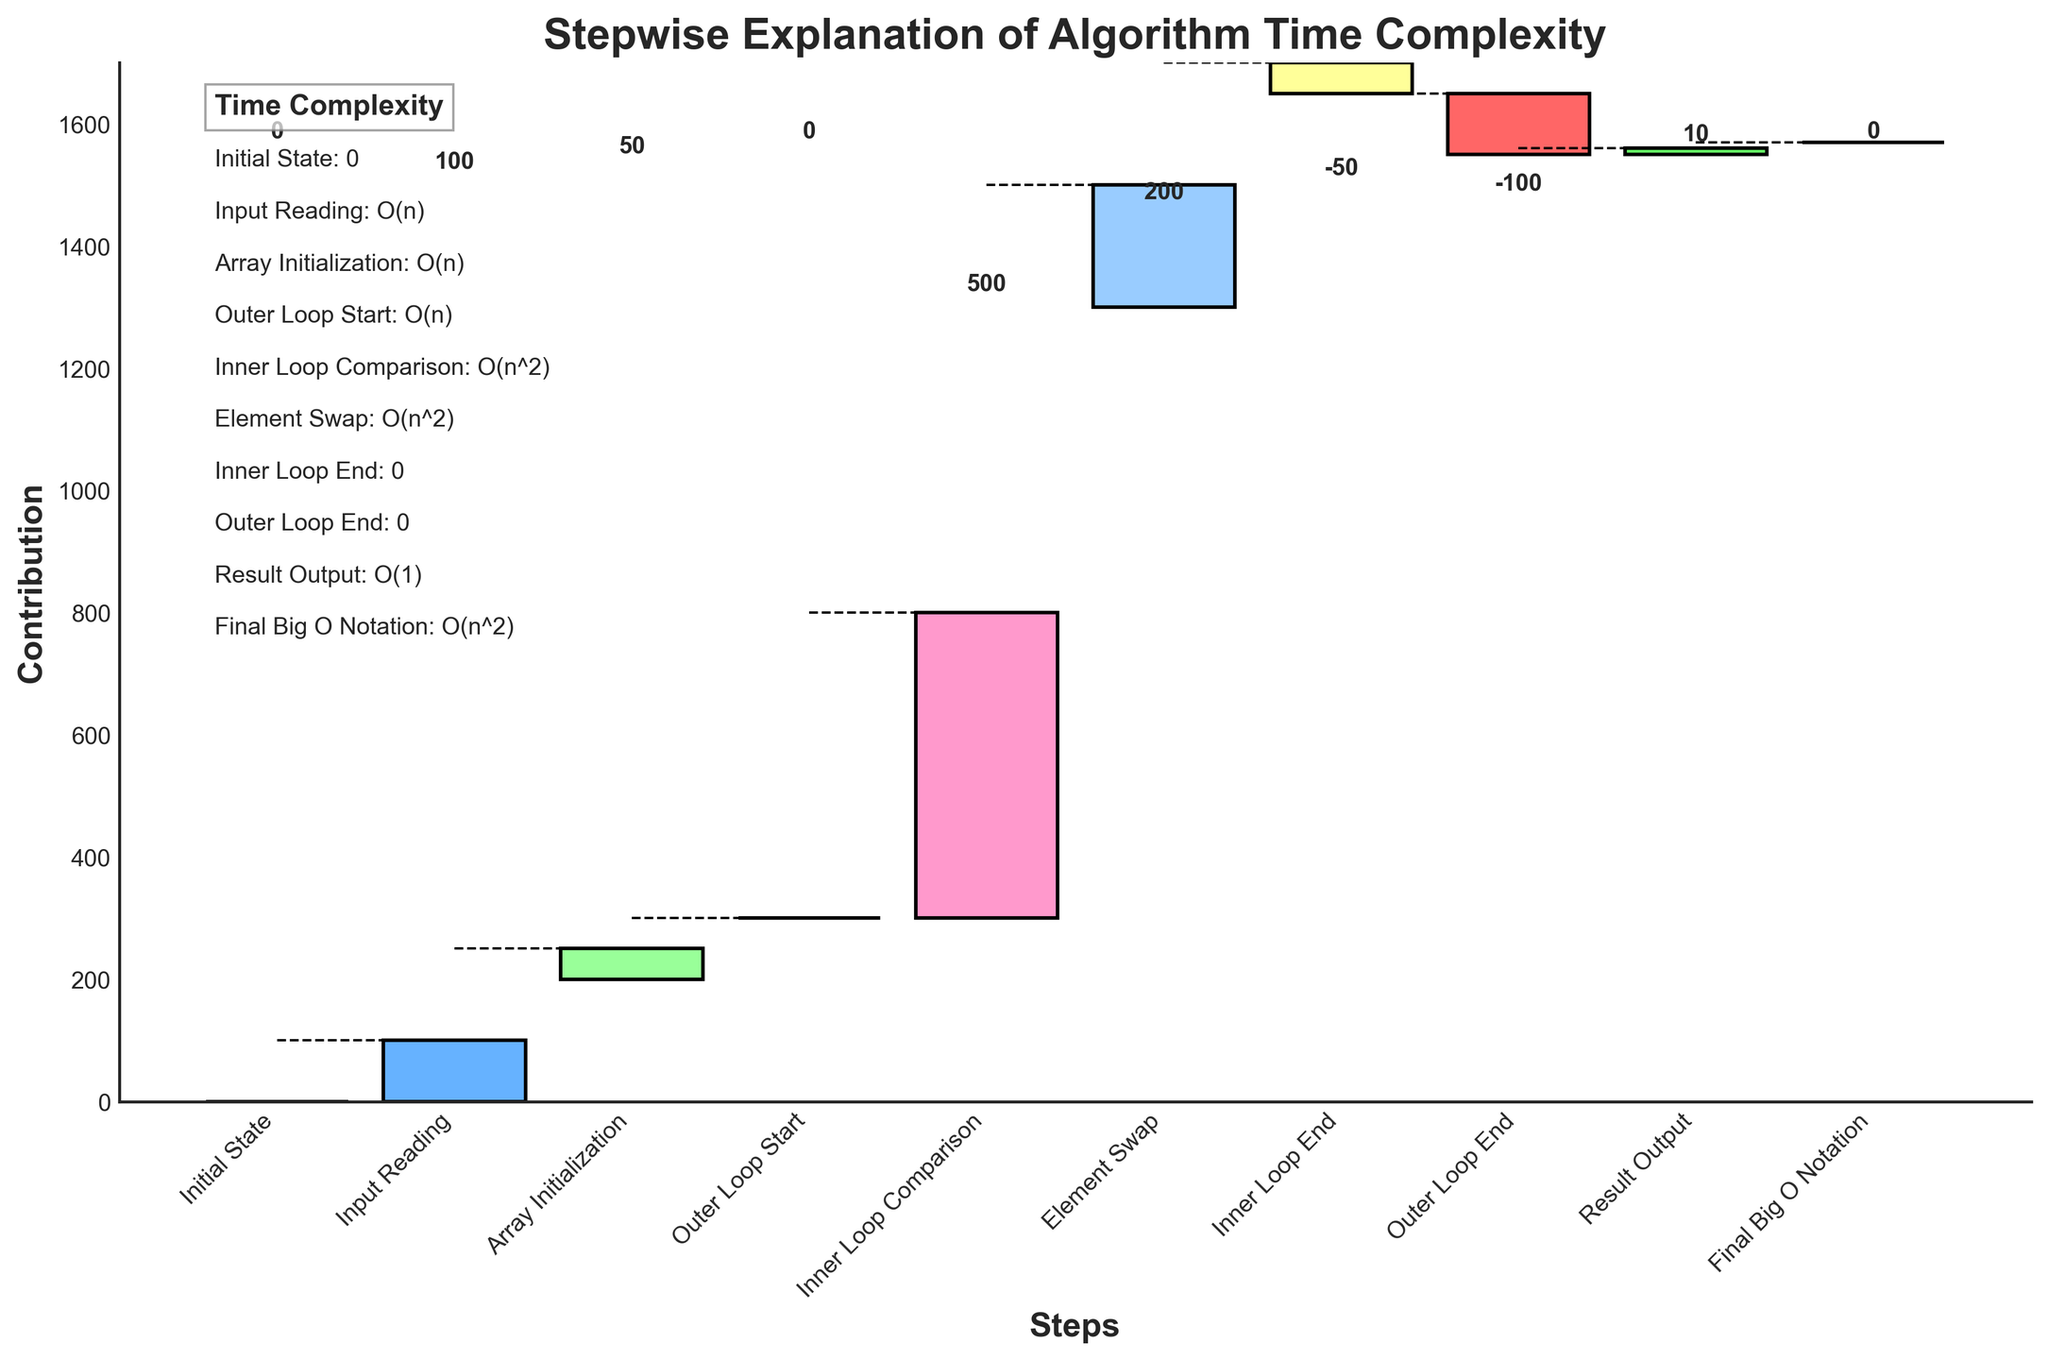What's the title of the chart? The title of the chart is generally located at the top of the figure. For this specific figure, it reads "Stepwise Explanation of Algorithm Time Complexity".
Answer: Stepwise Explanation of Algorithm Time Complexity Which step has the highest contribution value and what is it? Look for the step with the tallest bar in the positive direction. The "Inner Loop Comparison" step has the highest contribution value of 500.
Answer: Inner Loop Comparison, 500 By how much does the "Element Swap" step increase the contribution compared to the "Array Initialization" step? The contribution of the "Array Initialization" step is 50, and the "Element Swap" step is 200. The increase is calculated as 200 - 50 = 150.
Answer: 150 What is the color of the "Result Output" step bar? The "Result Output" step is the second-to-last bar in the chart. According to the description, colors are used in a recurring sequence; this one is light green among the mentioned colors.
Answer: light green Which steps have a negative contribution, and what are their values? Identify bars that extend downwards from the bottom level. The steps "Inner Loop End" and "Outer Loop End" have negative contributions of -50 and -100, respectively.
Answer: Inner Loop End: -50, Outer Loop End: -100 What is the total positive contribution before the final Big O notation? Sum up all the positive contributions: 100 (Input Reading) + 50 (Array Initialization) + 0 (Outer Loop Start) + 500 (Inner Loop Comparison) + 200 (Element Swap) + 10 (Result Output) = 860.
Answer: 860 Which step marks the beginning of nested loops, and what is its contribution? Locate the step indicating the start of loops; "Outer Loop Start" marks the beginning of the outer loop, with a contribution of 0.
Answer: Outer Loop Start, 0 How does the contribution of the "Input Reading" step compare to that of the "Result Output" step? The "Input Reading" step has a contribution of 100, while the "Result Output" step has a contribution of 10. The "Input Reading" step's contribution is greater.
Answer: Input Reading is greater If you were to combine the contributions of the "Inner Loop End" and "Outer Loop End" steps, what would be the result? Add the values of the two steps: -50 (Inner Loop End) + -100 (Outer Loop End) = -150.
Answer: -150 What is the overall trend from the "Initial State" to the "Final Big O Notation"? Examine the sum of all contributions. The trend starts from 0, increases with positive contributions, and then decreases with negative contributions, stabilizing at 0 for the final Big O notation, showing the incremental and decremental steps leading to the final complex form.
Answer: Increment-decrement to stabilize at 0 